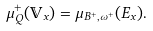Convert formula to latex. <formula><loc_0><loc_0><loc_500><loc_500>\mu _ { Q } ^ { + } ( \mathbb { V } _ { x } ) = \mu _ { B ^ { + } , \omega ^ { + } } ( E _ { x } ) .</formula> 